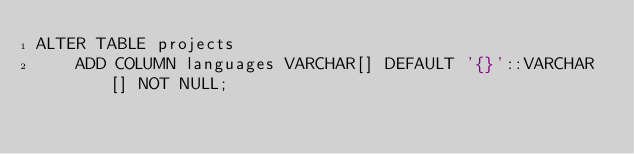<code> <loc_0><loc_0><loc_500><loc_500><_SQL_>ALTER TABLE projects
    ADD COLUMN languages VARCHAR[] DEFAULT '{}'::VARCHAR[] NOT NULL;</code> 